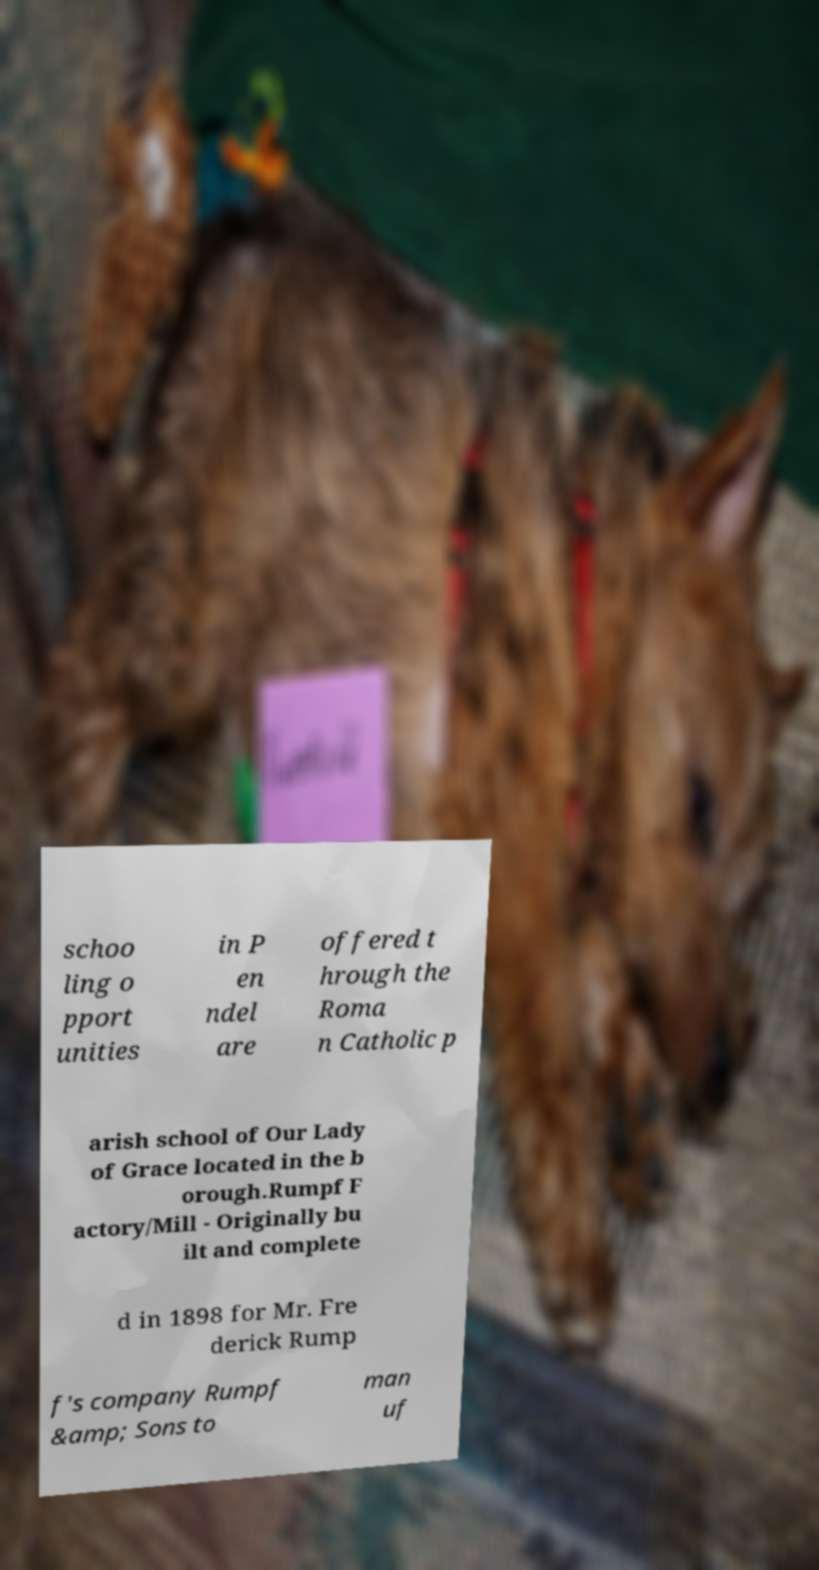Could you extract and type out the text from this image? schoo ling o pport unities in P en ndel are offered t hrough the Roma n Catholic p arish school of Our Lady of Grace located in the b orough.Rumpf F actory/Mill - Originally bu ilt and complete d in 1898 for Mr. Fre derick Rump f's company Rumpf &amp; Sons to man uf 